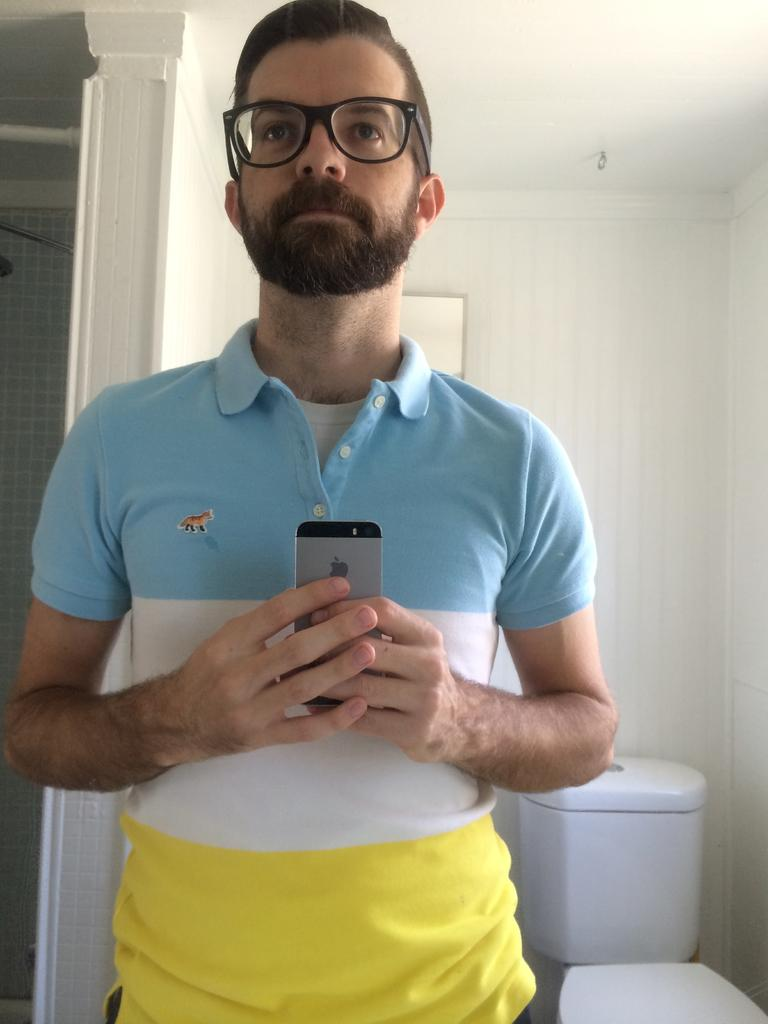Who is present in the image? There is a man in the image. What is the man holding in his hand? The man is holding a mobile in his hand. What can be seen in the background of the image? There is a wall and a toilet seat in the background of the image. How does the man's wealth affect the appearance of the toilet seat in the image? The image does not provide any information about the man's wealth, so we cannot determine how it might affect the appearance of the toilet seat. 